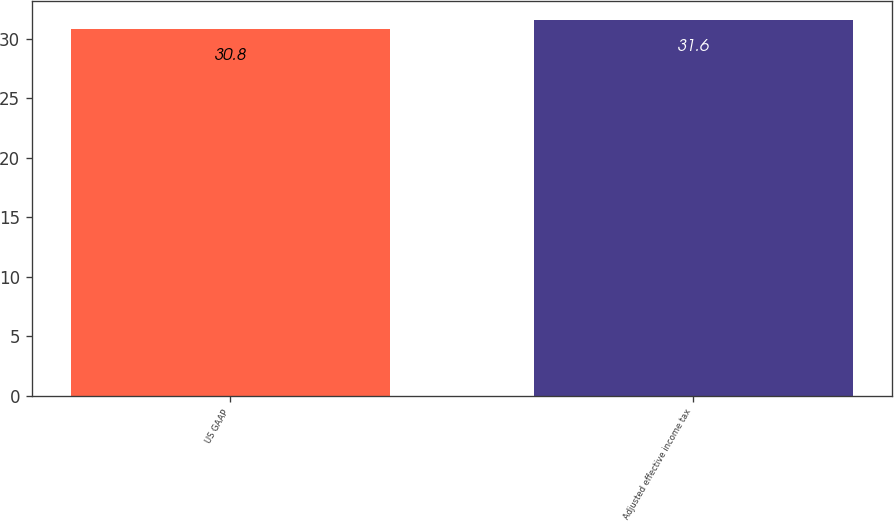Convert chart. <chart><loc_0><loc_0><loc_500><loc_500><bar_chart><fcel>US GAAP<fcel>Adjusted effective income tax<nl><fcel>30.8<fcel>31.6<nl></chart> 